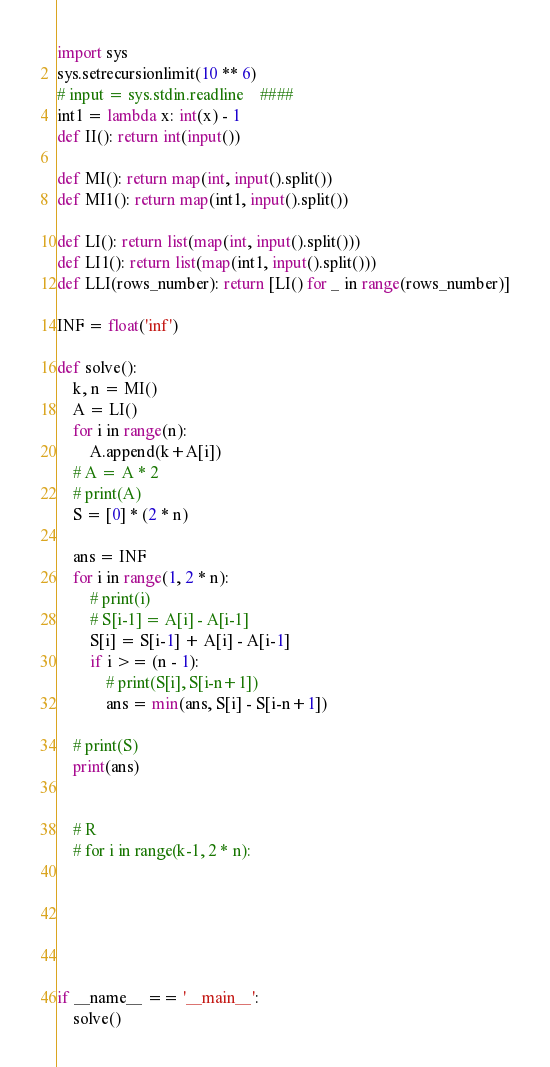<code> <loc_0><loc_0><loc_500><loc_500><_Python_>import sys
sys.setrecursionlimit(10 ** 6)
# input = sys.stdin.readline    ####
int1 = lambda x: int(x) - 1
def II(): return int(input())

def MI(): return map(int, input().split())
def MI1(): return map(int1, input().split())

def LI(): return list(map(int, input().split()))
def LI1(): return list(map(int1, input().split()))
def LLI(rows_number): return [LI() for _ in range(rows_number)]

INF = float('inf')

def solve():
    k, n = MI()
    A = LI()
    for i in range(n):
        A.append(k+A[i])
    # A = A * 2
    # print(A)
    S = [0] * (2 * n)

    ans = INF
    for i in range(1, 2 * n):
        # print(i)
        # S[i-1] = A[i] - A[i-1]
        S[i] = S[i-1] + A[i] - A[i-1]
        if i >= (n - 1):
            # print(S[i], S[i-n+1])
            ans = min(ans, S[i] - S[i-n+1])

    # print(S)
    print(ans)


    # R
    # for i in range(k-1, 2 * n):






if __name__ == '__main__':
    solve()
</code> 